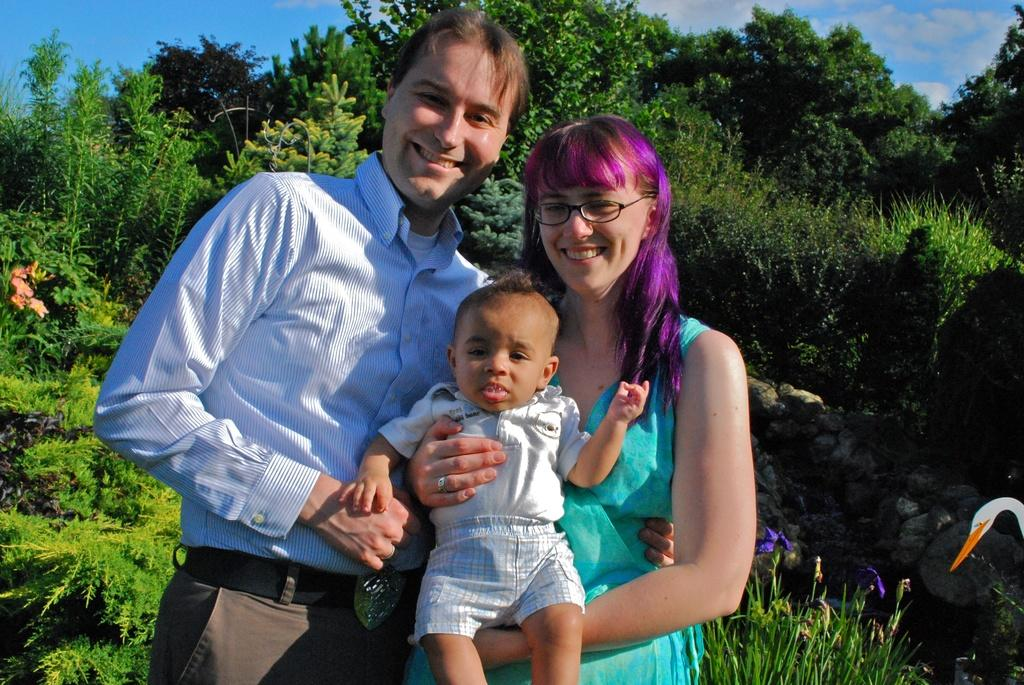How many people are in the image? There are two people in the image, a man and a woman. What are the man and woman doing in the image? The man and woman are standing and smiling in the image. Who is holding the child in the image? The woman is holding the child in the image. What can be seen in the background of the image? There are plants, trees, and the sky visible in the background of the image. What type of tiger can be seen sleeping in the image? There is no tiger present in the image, and therefore no such activity can be observed. What time of day is it in the image, given that it is night? The sky is visible in the background of the image, and it appears to be daytime, not night. 